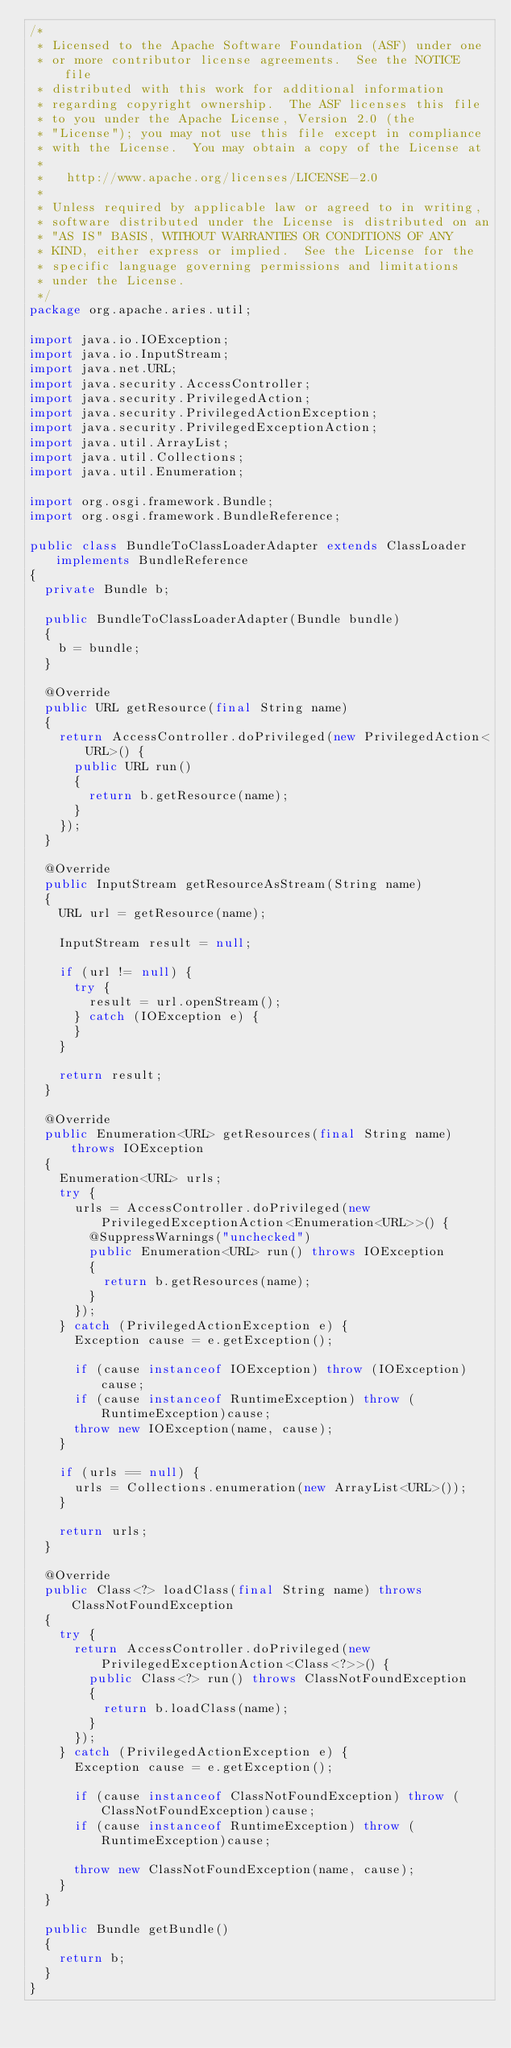<code> <loc_0><loc_0><loc_500><loc_500><_Java_>/*
 * Licensed to the Apache Software Foundation (ASF) under one
 * or more contributor license agreements.  See the NOTICE file
 * distributed with this work for additional information
 * regarding copyright ownership.  The ASF licenses this file
 * to you under the Apache License, Version 2.0 (the
 * "License"); you may not use this file except in compliance
 * with the License.  You may obtain a copy of the License at
 *
 *   http://www.apache.org/licenses/LICENSE-2.0
 *
 * Unless required by applicable law or agreed to in writing,
 * software distributed under the License is distributed on an
 * "AS IS" BASIS, WITHOUT WARRANTIES OR CONDITIONS OF ANY
 * KIND, either express or implied.  See the License for the
 * specific language governing permissions and limitations
 * under the License.
 */
package org.apache.aries.util;

import java.io.IOException;
import java.io.InputStream;
import java.net.URL;
import java.security.AccessController;
import java.security.PrivilegedAction;
import java.security.PrivilegedActionException;
import java.security.PrivilegedExceptionAction;
import java.util.ArrayList;
import java.util.Collections;
import java.util.Enumeration;

import org.osgi.framework.Bundle;
import org.osgi.framework.BundleReference;

public class BundleToClassLoaderAdapter extends ClassLoader implements BundleReference
{
  private Bundle b;

  public BundleToClassLoaderAdapter(Bundle bundle)
  {
    b = bundle;
  }

  @Override
  public URL getResource(final String name)
  {
    return AccessController.doPrivileged(new PrivilegedAction<URL>() {
      public URL run()
      {
        return b.getResource(name);
      }
    });
  }

  @Override
  public InputStream getResourceAsStream(String name)
  {
    URL url = getResource(name);

    InputStream result = null;

    if (url != null) {
      try {
        result = url.openStream();
      } catch (IOException e) {
      }
    }

    return result;
  }

  @Override
  public Enumeration<URL> getResources(final String name) throws IOException
  {
    Enumeration<URL> urls;
    try {
      urls = AccessController.doPrivileged(new PrivilegedExceptionAction<Enumeration<URL>>() {
        @SuppressWarnings("unchecked")
        public Enumeration<URL> run() throws IOException
        {
          return b.getResources(name);
        }
      });
    } catch (PrivilegedActionException e) {
      Exception cause = e.getException();

      if (cause instanceof IOException) throw (IOException)cause;
      if (cause instanceof RuntimeException) throw (RuntimeException)cause;
      throw new IOException(name, cause);
    }

    if (urls == null) {
      urls = Collections.enumeration(new ArrayList<URL>());
    }

    return urls;
  }

  @Override
  public Class<?> loadClass(final String name) throws ClassNotFoundException
  {
    try {
      return AccessController.doPrivileged(new PrivilegedExceptionAction<Class<?>>() {
        public Class<?> run() throws ClassNotFoundException
        {
          return b.loadClass(name);
        }
      });
    } catch (PrivilegedActionException e) {
      Exception cause = e.getException();

      if (cause instanceof ClassNotFoundException) throw (ClassNotFoundException)cause;
      if (cause instanceof RuntimeException) throw (RuntimeException)cause;

      throw new ClassNotFoundException(name, cause);
    }
  }

  public Bundle getBundle()
  {
    return b;
  }
}</code> 